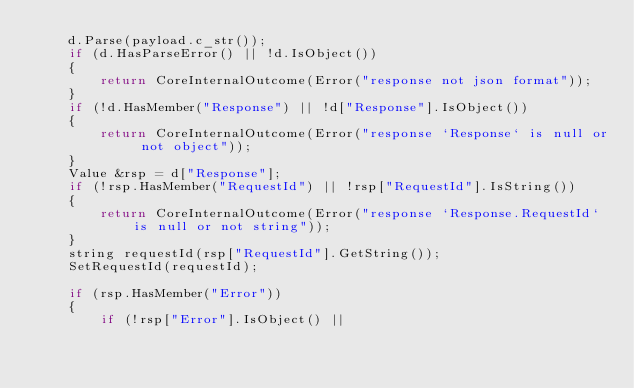<code> <loc_0><loc_0><loc_500><loc_500><_C++_>    d.Parse(payload.c_str());
    if (d.HasParseError() || !d.IsObject())
    {
        return CoreInternalOutcome(Error("response not json format"));
    }
    if (!d.HasMember("Response") || !d["Response"].IsObject())
    {
        return CoreInternalOutcome(Error("response `Response` is null or not object"));
    }
    Value &rsp = d["Response"];
    if (!rsp.HasMember("RequestId") || !rsp["RequestId"].IsString())
    {
        return CoreInternalOutcome(Error("response `Response.RequestId` is null or not string"));
    }
    string requestId(rsp["RequestId"].GetString());
    SetRequestId(requestId);

    if (rsp.HasMember("Error"))
    {
        if (!rsp["Error"].IsObject() ||</code> 